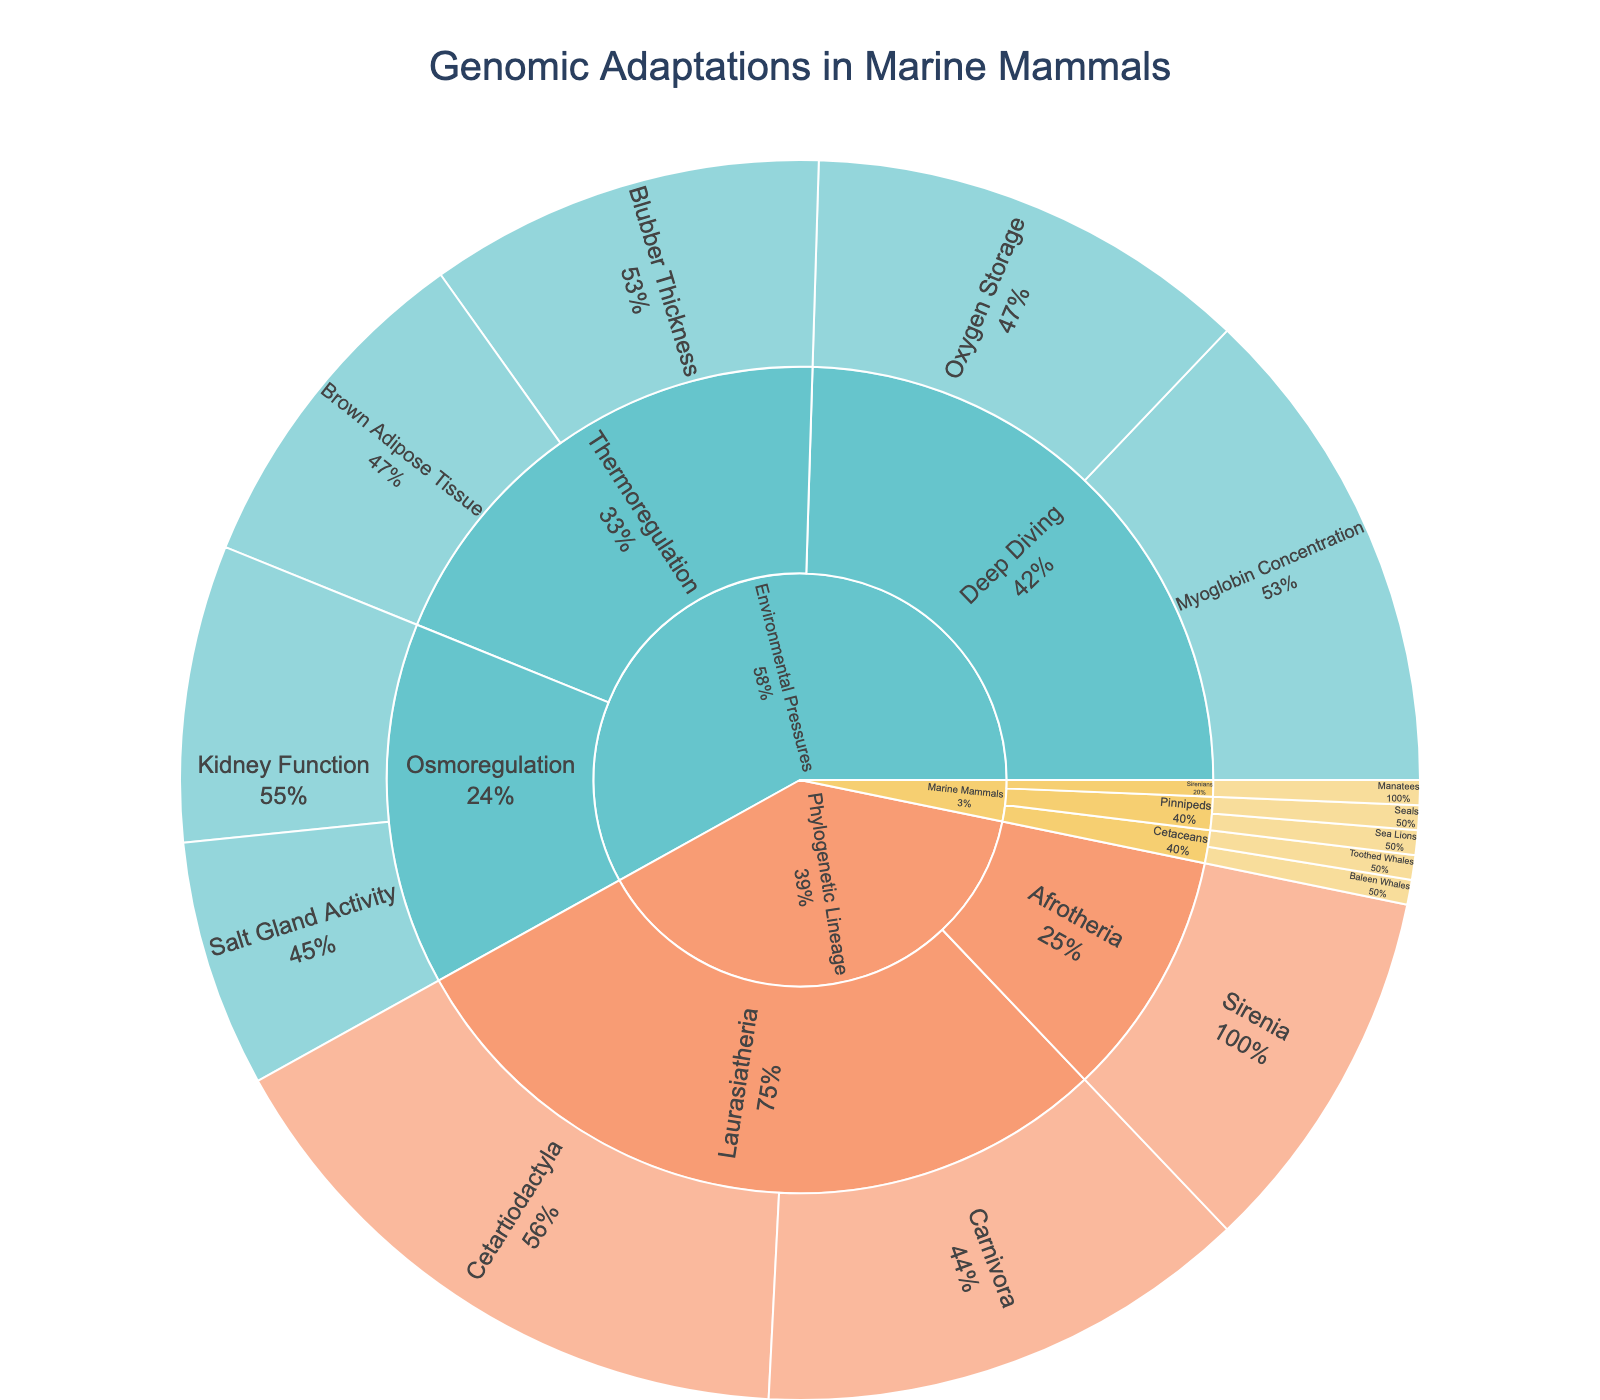what is the title of the plot? The title can be found at the top of the plot and it reads "Genomic Adaptations in Marine Mammals".
Answer: Genomic Adaptations in Marine Mammals How many primary categories are displayed in the sunburst plot? There are three primary categories for the first level of the plot: "Marine Mammals", "Environmental Pressures", and "Phylogenetic Lineage". Count the segments at the outermost ring level.
Answer: Three What is the largest subcategory under the "Environmental Pressures" category? Under "Environmental Pressures", there are three subcategories: "Deep Diving", "Thermoregulation", and "Osmoregulation". Look at the size of each segment to see that "Deep Diving" has the largest segments combined.
Answer: Deep Diving What percentage does "Blubber Thickness" contribute to "Thermoregulation"? Identify the portion of "Thermoregulation" taken up by "Blubber Thickness". Noting that "Thermoregulation" ultimately has a total of 30 (16 for "Blubber Thickness" and 14 for "Brown Adipose Tissue"), "Blubber Thickness" makes up 16 out of 30, which is approximately 53.3%.
Answer: 53.3% Which subcategory of phylogenetic lineage has the highest value, and what is that value? Look at the "Phylogenetic Lineage" category and its subcategories. Identify the maximum value among "Cetartiodactyla" (25), "Carnivora" (20), and "Sirenia" (15). The highest value is "Cetartiodactyla" with a value of 25.
Answer: Cetartiodactyla, 25 How does the value for "Myoglobin Concentration" compare to "Blubber Thickness"? Compare the value of "Myoglobin Concentration" (20) under "Deep Diving" to "Blubber Thickness" (16) under "Thermoregulation". 20 is greater than 16.
Answer: Myoglobin Concentration is greater What is the combined value for "Oxygen Storage" and "Kidney Function"? Sum the values of "Oxygen Storage" (18) and "Kidney Function" (12). 18 + 12 = 30.
Answer: 30 Which lineage under "Phylogenetic Lineage" does "Toothed Whales" belong to? Under the "Phylogenetic Lineage" category, "Toothed Whales" falls under "Cetaceans" which is a subcategory of "Laurasiatheria" in the phylogenetic sunburst classification.
Answer: Laurasiatheria Compare the total values of "Cetaceans" and "Pinnipeds" under the "Marine Mammals" category. Identify the segments under "Cetaceans" and "Pinnipeds". "Cetaceans" include "Baleen Whales" and "Toothed Whales" (unlabeled but presumed 1 each), and "Pinnipeds" include "Seals" and "Sea Lions" (unlabeled but presumed 1 each). Both total to around 2 or unknown, showing they are approximately equal.
Answer: Approximately equal Which has a larger value: "Salt Gland Activity" or "Brown Adipose Tissue"? Compare the values of "Salt Gland Activity" (10) in "Osmoregulation" and "Brown Adipose Tissue" (14) in "Thermoregulation". The value for "Brown Adipose Tissue" is larger.
Answer: Brown Adipose Tissue 